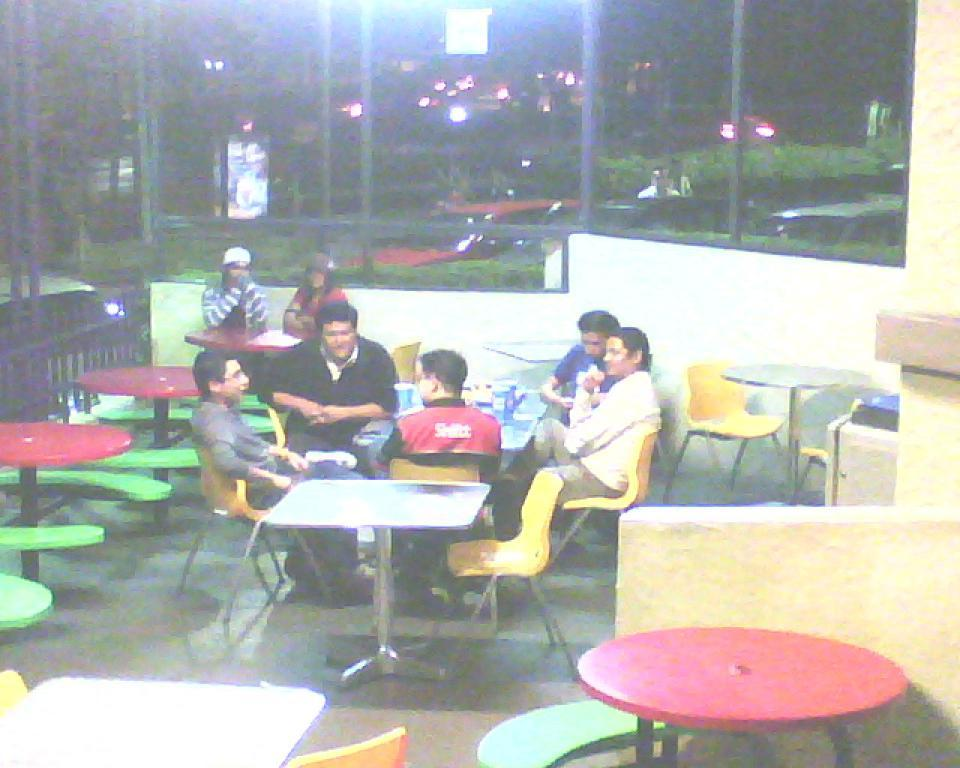How many people are in the image? There is a group of people in the image, but the exact number is not specified. What are the people doing in the image? The people are seated on chairs in the image. What other objects can be seen in the image besides the people? There are tables and trees visible in the image. What can be used to provide illumination in the image? There is a light in the image. What type of bucket is being used to promote peace in the image? There is no bucket or reference to peace in the image. 